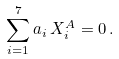Convert formula to latex. <formula><loc_0><loc_0><loc_500><loc_500>\sum _ { i = 1 } ^ { 7 } a _ { i } \, X _ { i } ^ { A } = 0 \, .</formula> 